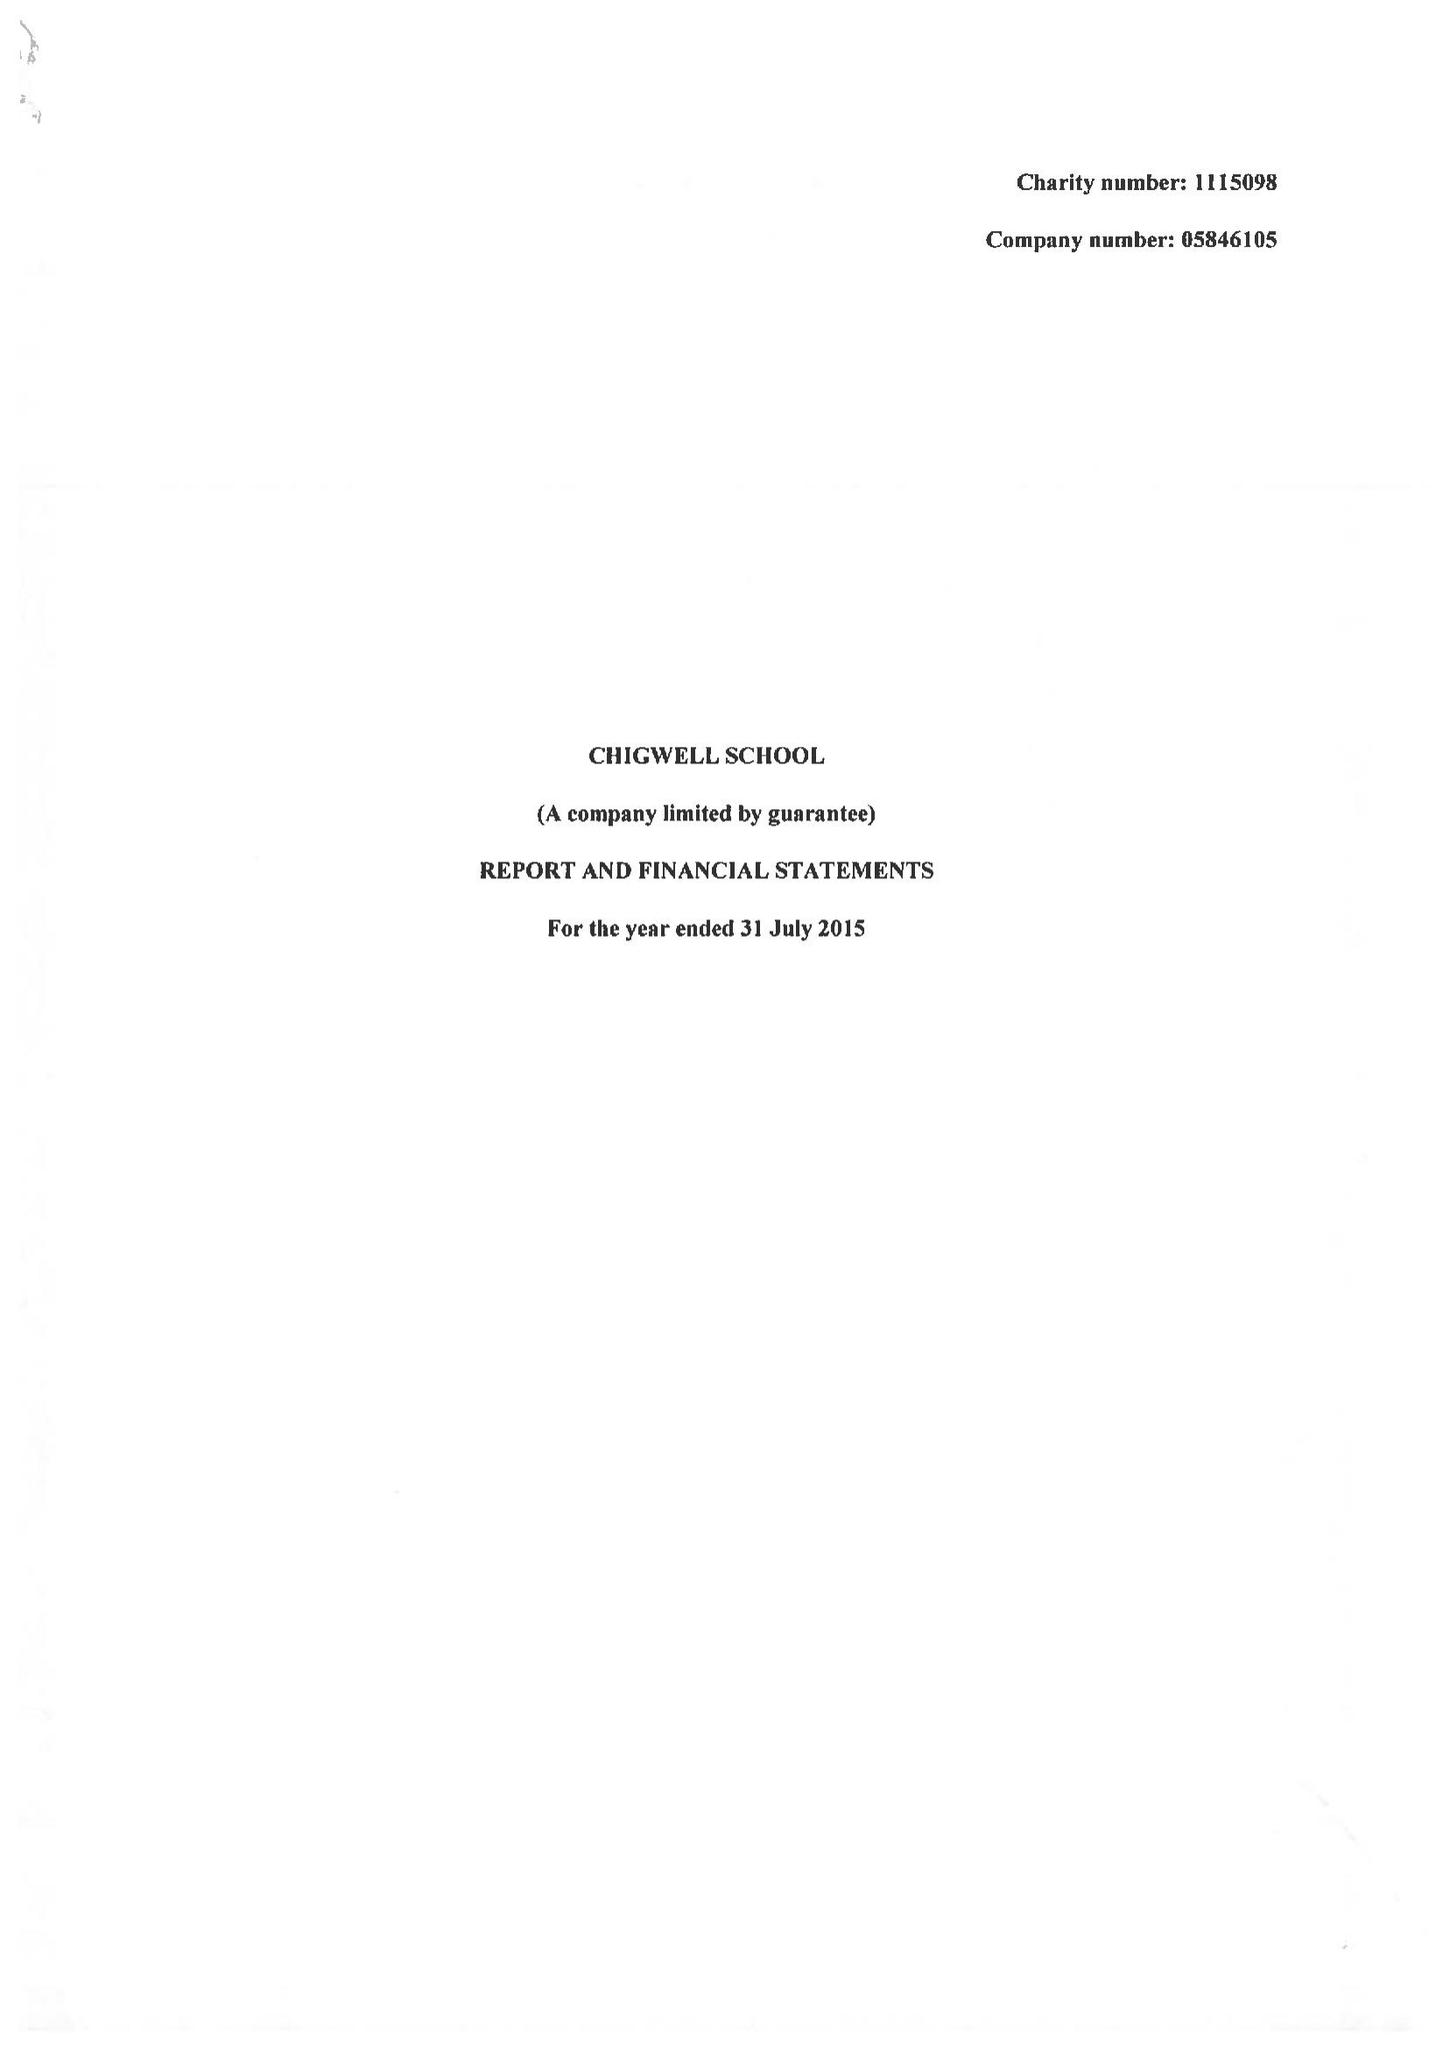What is the value for the charity_name?
Answer the question using a single word or phrase. Chigwell School 